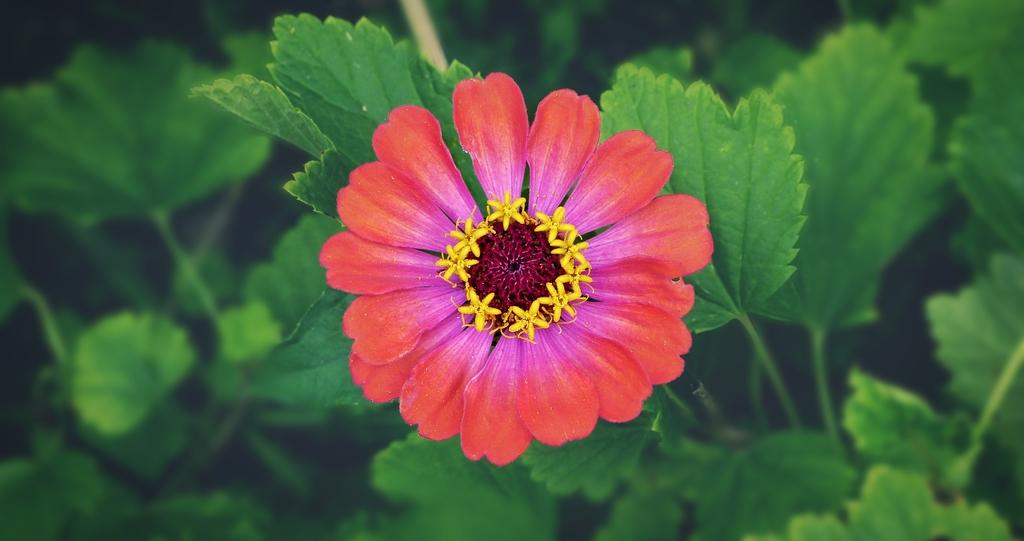What is the main subject of the image? There is a flower in the image. Can you describe the colors of the flower? The flower has red, pink, and yellow colors. What else can be seen in the background of the image? There are leaves in the background of the image. How would you describe the background of the image? The background appears slightly blurred. How many pencils are visible in the image? There are no pencils present in the image. What time of day is it in the image? The image does not provide any information about the time of day. 